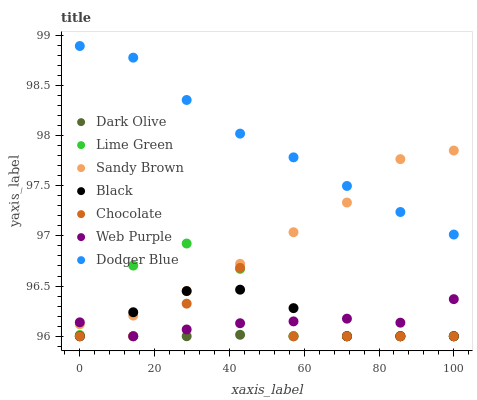Does Dark Olive have the minimum area under the curve?
Answer yes or no. Yes. Does Dodger Blue have the maximum area under the curve?
Answer yes or no. Yes. Does Chocolate have the minimum area under the curve?
Answer yes or no. No. Does Chocolate have the maximum area under the curve?
Answer yes or no. No. Is Dark Olive the smoothest?
Answer yes or no. Yes. Is Chocolate the roughest?
Answer yes or no. Yes. Is Chocolate the smoothest?
Answer yes or no. No. Is Dark Olive the roughest?
Answer yes or no. No. Does Lime Green have the lowest value?
Answer yes or no. Yes. Does Dodger Blue have the lowest value?
Answer yes or no. No. Does Dodger Blue have the highest value?
Answer yes or no. Yes. Does Chocolate have the highest value?
Answer yes or no. No. Is Dark Olive less than Sandy Brown?
Answer yes or no. Yes. Is Dodger Blue greater than Black?
Answer yes or no. Yes. Does Lime Green intersect Web Purple?
Answer yes or no. Yes. Is Lime Green less than Web Purple?
Answer yes or no. No. Is Lime Green greater than Web Purple?
Answer yes or no. No. Does Dark Olive intersect Sandy Brown?
Answer yes or no. No. 